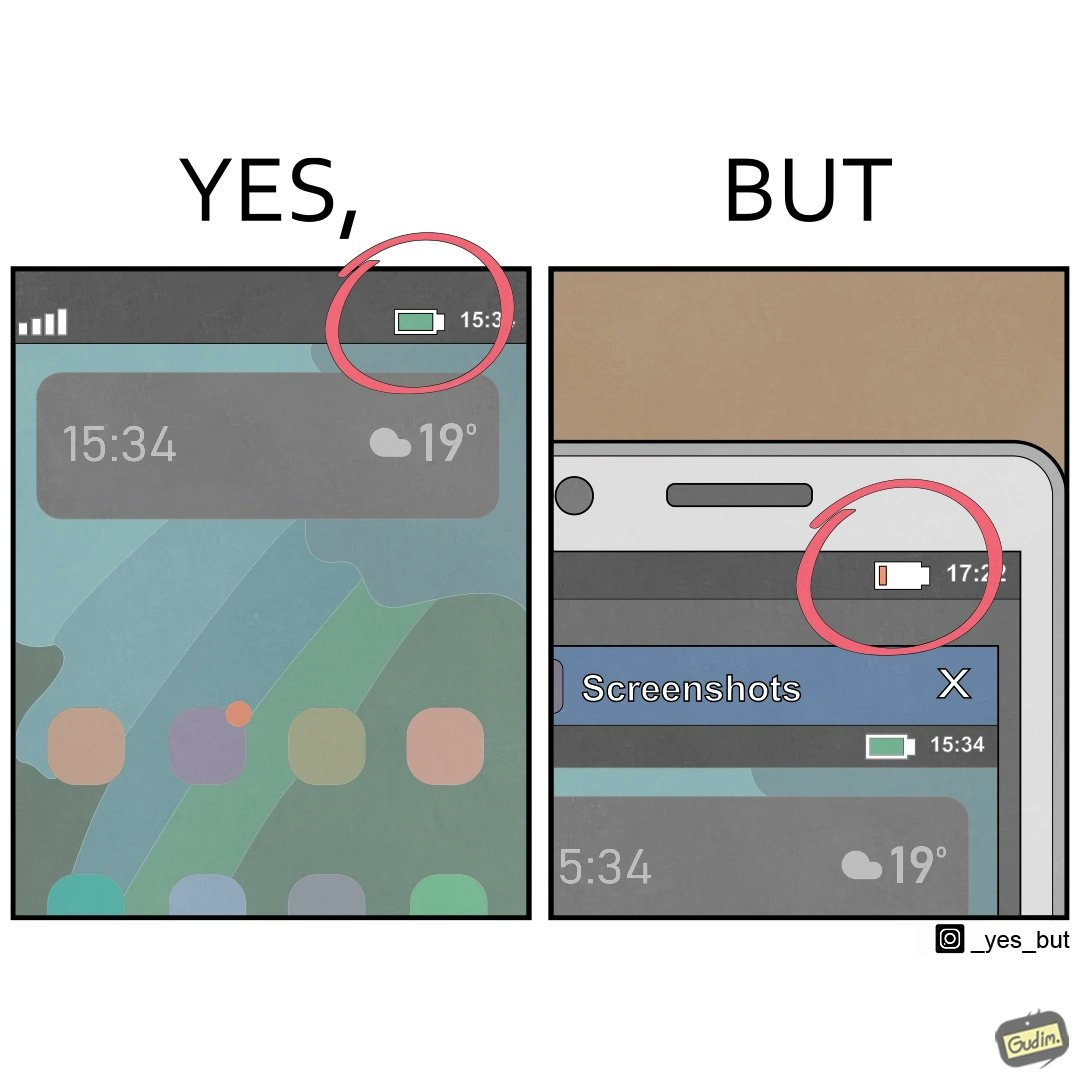What is shown in the left half versus the right half of this image? In the left part of the image: an image of home screen of a phone with 100% battery in red circle In the right part of the image: an image of screen of a phone with a screenshot open with a low battery percentage 